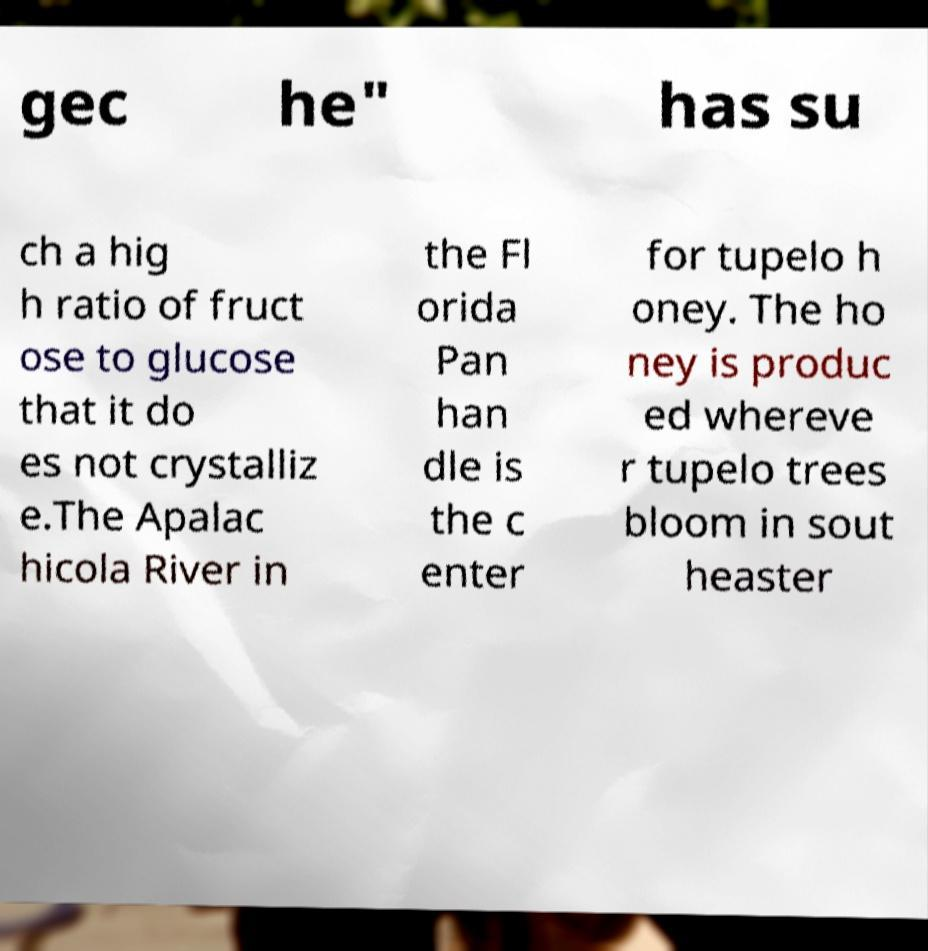Can you accurately transcribe the text from the provided image for me? gec he" has su ch a hig h ratio of fruct ose to glucose that it do es not crystalliz e.The Apalac hicola River in the Fl orida Pan han dle is the c enter for tupelo h oney. The ho ney is produc ed whereve r tupelo trees bloom in sout heaster 